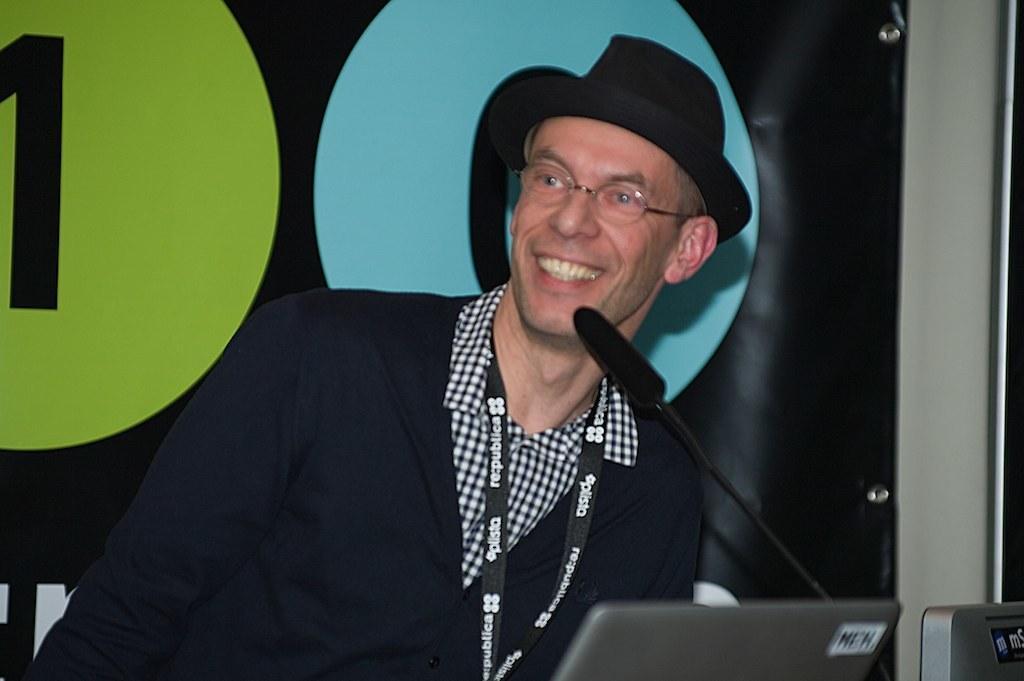Could you give a brief overview of what you see in this image? At the bottom of the image there are laptops and also there is a mic. Behind them there is a man with a hat on his head and he kept spectacles. And he is smiling. Behind him there is a banner. 